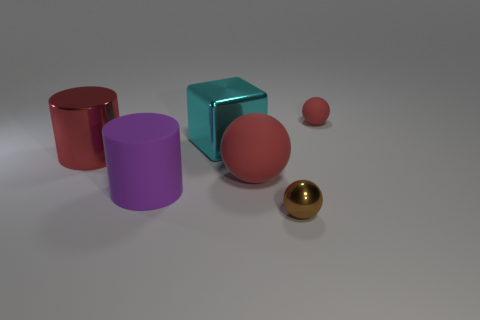There is a matte ball that is behind the block; is it the same size as the big purple matte thing?
Keep it short and to the point. No. How many shiny things are either brown spheres or large things?
Your answer should be compact. 3. What material is the ball that is both behind the tiny brown shiny object and in front of the cyan metallic object?
Your answer should be compact. Rubber. Does the large cyan object have the same material as the brown ball?
Your answer should be very brief. Yes. What size is the thing that is both right of the large red ball and behind the big purple cylinder?
Offer a terse response. Small. What is the shape of the small brown thing?
Offer a very short reply. Sphere. What number of objects are either tiny rubber balls or red things left of the large red matte ball?
Offer a very short reply. 2. Is the color of the big cylinder on the left side of the purple cylinder the same as the tiny rubber object?
Your answer should be compact. Yes. There is a shiny object that is both right of the big purple cylinder and behind the purple matte cylinder; what color is it?
Your response must be concise. Cyan. What material is the big object behind the red metallic cylinder?
Your response must be concise. Metal. 